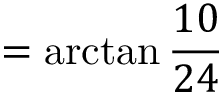<formula> <loc_0><loc_0><loc_500><loc_500>= \arctan { \frac { 1 0 } { 2 4 } }</formula> 